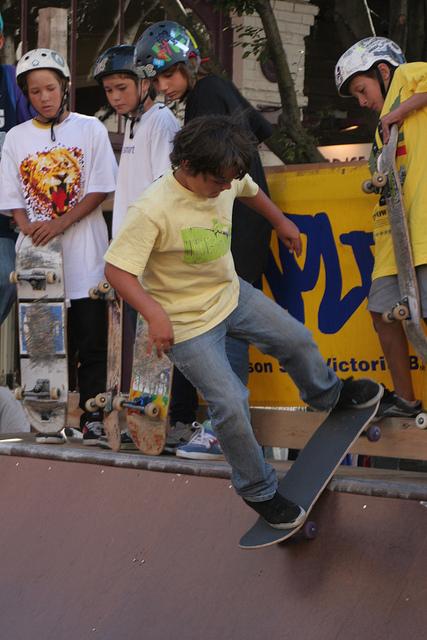Is everyone admiring the skaters?
Concise answer only. Yes. Are both men playing?
Give a very brief answer. No. How many kids are wearing helmets?
Quick response, please. 4. Is the man practicing the sport safely?
Write a very short answer. No. What is the kid doing?
Give a very brief answer. Skateboarding. What are they waiting to do?
Keep it brief. Skateboard. 